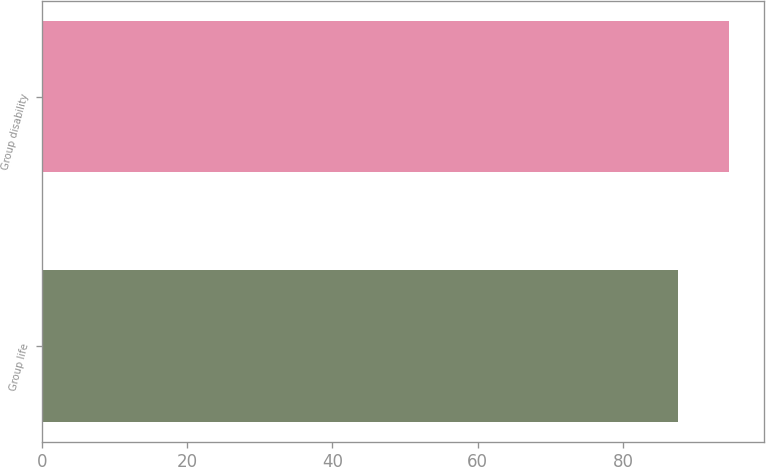Convert chart to OTSL. <chart><loc_0><loc_0><loc_500><loc_500><bar_chart><fcel>Group life<fcel>Group disability<nl><fcel>87.5<fcel>94.6<nl></chart> 